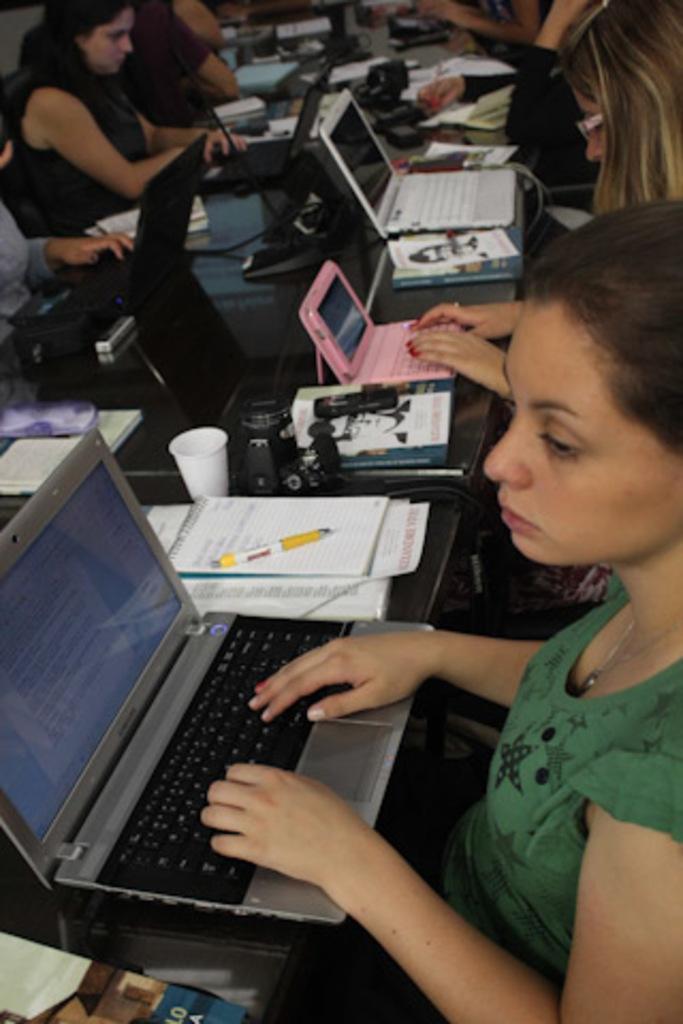How would you summarize this image in a sentence or two? In this picture there is a table in the center of the image, on which there are laptops and books, there are people those who are sitting around the table. 